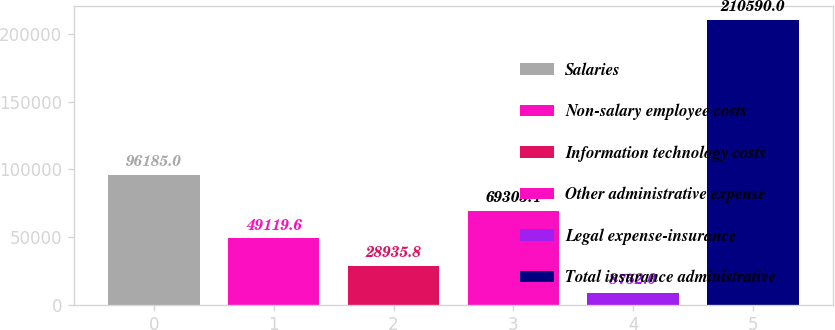Convert chart. <chart><loc_0><loc_0><loc_500><loc_500><bar_chart><fcel>Salaries<fcel>Non-salary employee costs<fcel>Information technology costs<fcel>Other administrative expense<fcel>Legal expense-insurance<fcel>Total insurance administrative<nl><fcel>96185<fcel>49119.6<fcel>28935.8<fcel>69303.4<fcel>8752<fcel>210590<nl></chart> 